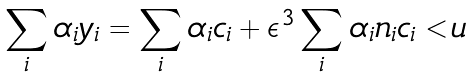<formula> <loc_0><loc_0><loc_500><loc_500>\sum _ { i } \alpha _ { i } y _ { i } = \sum _ { i } \alpha _ { i } c _ { i } + \boldsymbol \epsilon ^ { 3 } \sum _ { i } \alpha _ { i } n _ { i } c _ { i } < u</formula> 